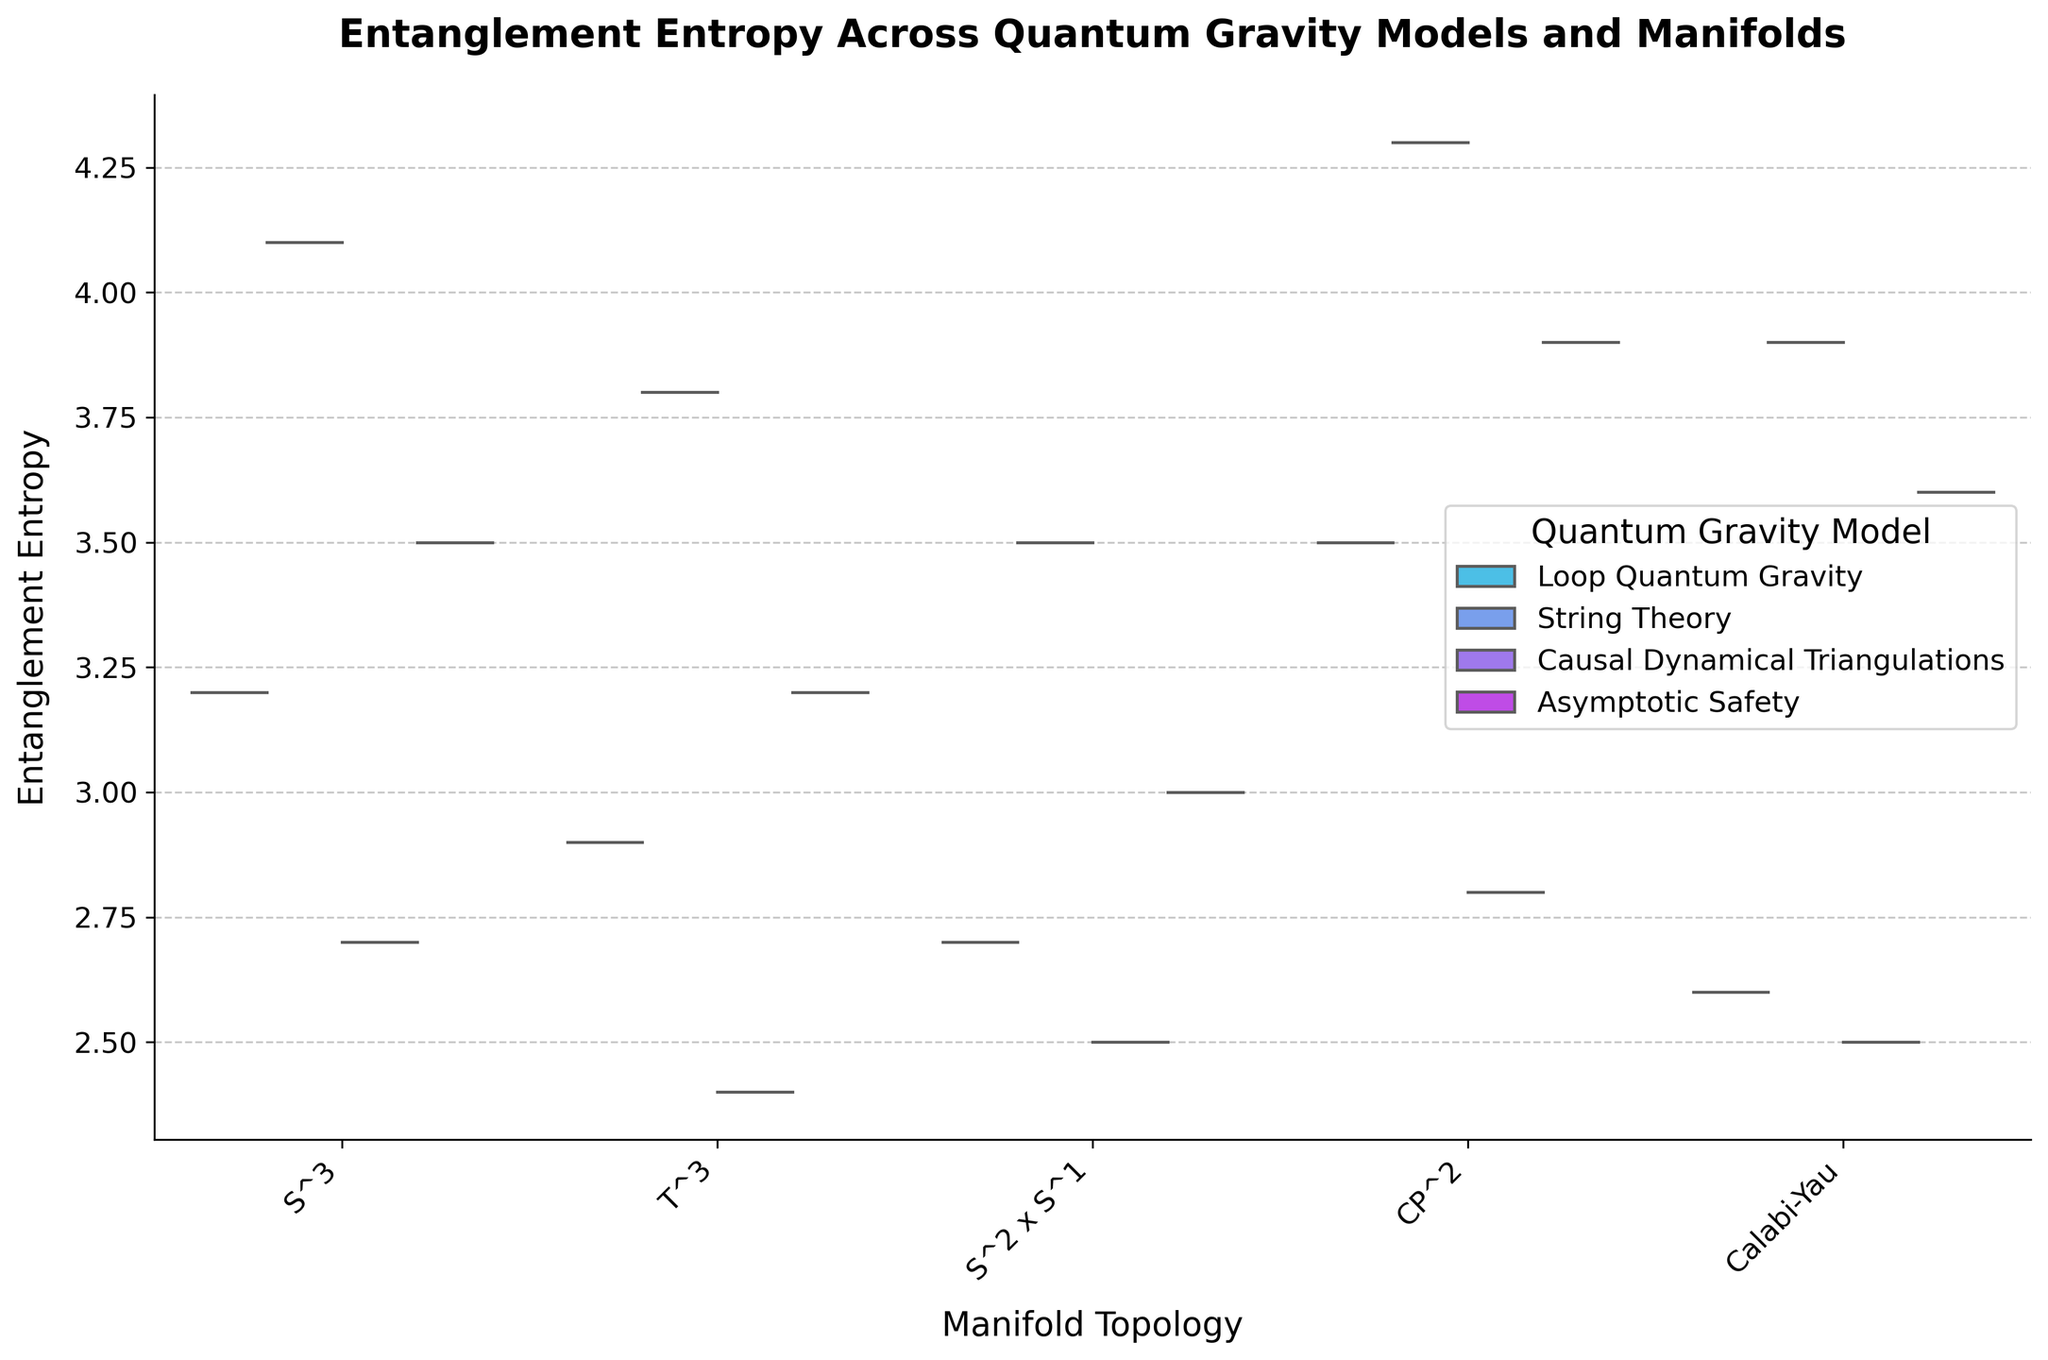What is the title of the figure? The title of the figure is prominently placed at the top of the chart. It summarizes the entire plot and indicates the content and purpose of the visualization. In this case, it reads, "Entanglement Entropy Across Quantum Gravity Models and Manifolds".
Answer: Entanglement Entropy Across Quantum Gravity Models and Manifolds What are the labels of the x-axis and y-axis? The labels of the axes are crucial as they provide context for what is being plotted. The x-axis represents "Manifold Topology" and the y-axis represents "Entanglement Entropy". These labels indicate that the plot shows how entanglement entropy varies across different manifold topologies.
Answer: Manifold Topology, Entanglement Entropy Which quantum gravity model shows the highest entanglement entropy for the CP^2 manifold? By visually inspecting the distribution for CP^2, we look for the highest value in the violin plot with box plot overlay. For CP^2, String Theory shows the highest entanglement entropy.
Answer: String Theory What is the general trend of entanglement entropy for the manifold Calabi-Yau across different models? To determine the trend, we look at the distributions of entanglement entropy for Calabi-Yau in all models. String Theory and Asymptotic Safety have higher median entanglement entropies whereas Loop Quantum Gravity and Causal Dynamical Triangulations lie lower.
Answer: Higher in String Theory and Asymptotic Safety, lower in Loop Quantum Gravity and Causal Dynamical Triangulations Comparing Loop Quantum Gravity and Causal Dynamical Triangulations, which model exhibits greater variation in entanglement entropy? We assess the spread and density of the violins and the box plot whiskers to measure variation. The violin for Loop Quantum Gravity appears broader and more varied compared to Causal Dynamical Triangulations.
Answer: Loop Quantum Gravity For which manifold topology is the variation in entanglement entropy the least pronounced across all models? By examining the spread of the violins for all models for each manifold topology, S^2 x S^1 shows the least pronounced variation as the violins are less spread out.
Answer: S^2 x S^1 Which quantum gravity model has the median entanglement entropy closest to 3.0 for the S^3 manifold? By looking at the box plots within the violins for S^3, we see that Asymptotic Safety has a median entanglement entropy closest to 3.0.
Answer: Asymptotic Safety How does the entanglement entropy of the T^3 manifold in String Theory compare to that in Loop Quantum Gravity? We compare the violin distributions and median lines for T^3 across the two models. Entanglement entropy in String Theory is higher both in terms of median and general spread compared to Loop Quantum Gravity.
Answer: Higher in String Theory Which model has the smallest range of entanglement entropy values for the S^3 manifold? The range of entanglement entropy is defined by the whiskers of the box plot inside the violin. Causal Dynamical Triangulations has the smallest range for the S^3 manifold.
Answer: Causal Dynamical Triangulations 